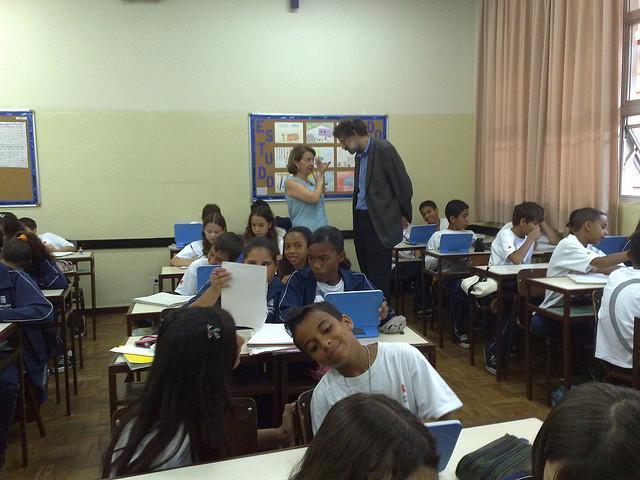How many people are there?
Give a very brief answer. 11. How many refrigerators are in this image?
Give a very brief answer. 0. 